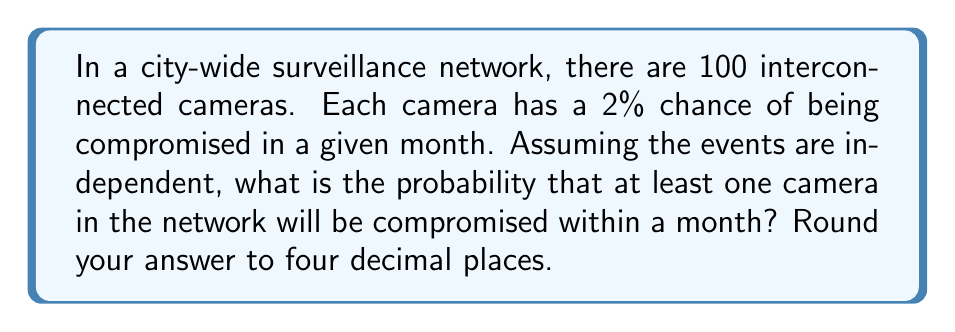Can you answer this question? Let's approach this step-by-step using probability theory:

1) First, let's consider the probability of a single camera not being compromised:
   $P(\text{camera not compromised}) = 1 - 0.02 = 0.98$

2) For the entire network to be secure, all 100 cameras must not be compromised. Since the events are independent, we can multiply the probabilities:
   $P(\text{all cameras secure}) = 0.98^{100}$

3) The probability we're looking for is the opposite of this - the probability that at least one camera is compromised. This is the complement of the probability that all cameras are secure:
   $P(\text{at least one camera compromised}) = 1 - P(\text{all cameras secure})$

4) Let's calculate:
   $$\begin{align}
   P(\text{at least one camera compromised}) &= 1 - 0.98^{100} \\
   &= 1 - 0.13262376 \\
   &= 0.86737624
   \end{align}$$

5) Rounding to four decimal places:
   $0.86737624 \approx 0.8674$

This high probability underscores the need for stringent security measures and regulations in surveillance networks, as the risk of at least one breach in a large network is significant even when individual components have a relatively low risk.
Answer: 0.8674 